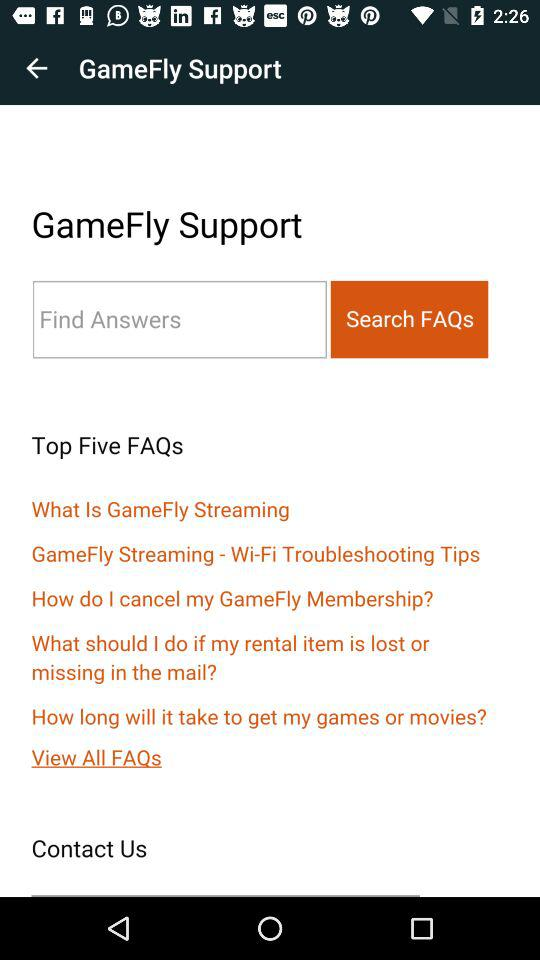How many FAQs are under the 'Top Five FAQs' section?
Answer the question using a single word or phrase. 5 